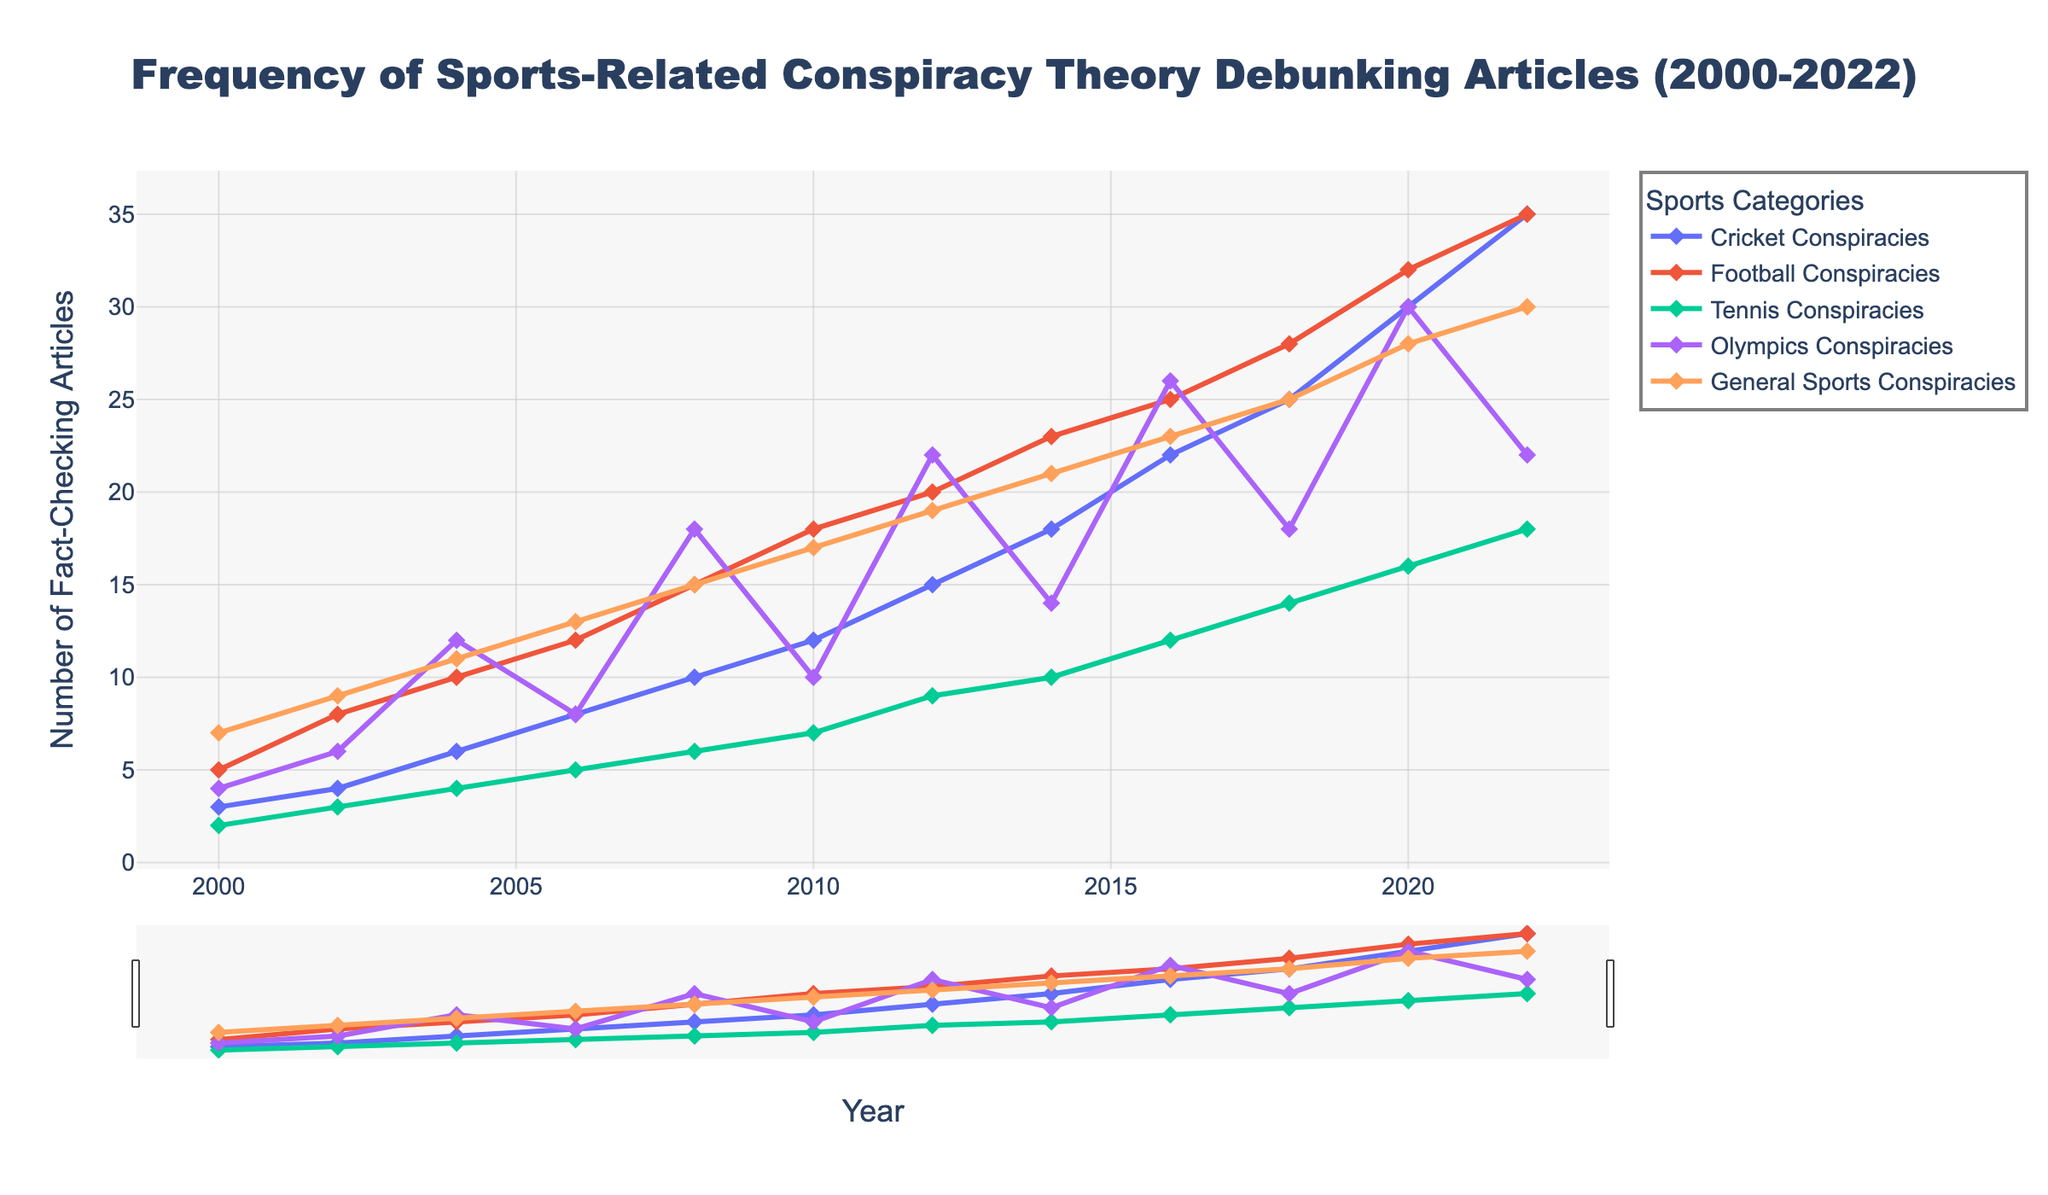What is the trend in the number of fact-checking articles on Cricket Conspiracies from 2000 to 2022? The line for Cricket Conspiracies shows an upward trend from 2000 to 2022, indicating a steady increase in the number of fact-checking articles over the years.
Answer: Increasing trend In which year did Football Conspiracies have the highest number of fact-checking articles, and what was the total? By examining the peak point of the line representing Football Conspiracies, the highest number is observed in 2022, where it reached 35 articles.
Answer: 2022, 35 articles How many total fact-checking articles were there for General Sports Conspiracies in 2016 and 2020 combined? In 2016, there were 23 articles, and in 2020, there were 28 articles. The sum of these is 23 + 28 = 51 articles.
Answer: 51 articles Which category had more fact-checking articles in 2018: Tennis Conspiracies or Olympics Conspiracies? In 2018, the line for Tennis Conspiracies reaches 14, while the line for Olympics Conspiracies reaches 18. Therefore, Olympics Conspiracies had more articles.
Answer: Olympics Conspiracies Compare the growth in fact-checking articles for Cricket Conspiracies and General Sports Conspiracies from 2010 to 2022. Which category had a greater increase? For Cricket, the increase from 2010 (12 articles) to 2022 (35 articles) is 35 - 12 = 23. For General Sports, the increase from 2010 (17 articles) to 2022 (30 articles) is 30 - 17 = 13. Cricket Conspiracies had a greater increase of 23 articles compared to 13 for General Sports.
Answer: Cricket Conspiracies Between 2004 and 2008, did the trend of Tennis Conspiracies fact-checking articles show a larger relative increase or decrease? In 2004, Tennis Conspiracies had 4 articles, whereas in 2008 it had 6 articles. The relative increase is (6 - 4) / 4 * 100 = 50%.
Answer: Larger relative increase What is the average number of fact-checking articles on Football Conspiracies from 2000 to 2022? Sum the articles from 2000 to 2022 for Football Conspiracies: 5, 8, 10, 12, 15, 18, 20, 23, 25, 28, 32, 35. Total sum = 231. Number of years = 12. Average = 231 / 12 ≈ 19.25.
Answer: 19.25 What year saw the first instance where the number of articles on Cricket Conspiracies surpassed the number of articles on Football Conspiracies from the previous year? Compare Cricket Conspiracies of each year to the previous year's Football Conspiracies: 2008 Cricket (10) vs. 2006 Football (12); 2010 Cricket (12) vs. 2008 Football (15); 2012 Cricket (15) vs. 2010 Football (18). First instance: 2016 Cricket (22) vs. 2014 Football (23). So, in 2020 Cricket (30) > 2018 Football (28).
Answer: 2020 In which year did all categories see an increase in fact-checking articles compared to the previous year? Except for small decreases or stagnations, each category was compared with previous years, such as from 2010 to 2012, 2012 to 2014, etc. The year 2010 to 2012 signifies an increase for all categories.
Answer: 2012 